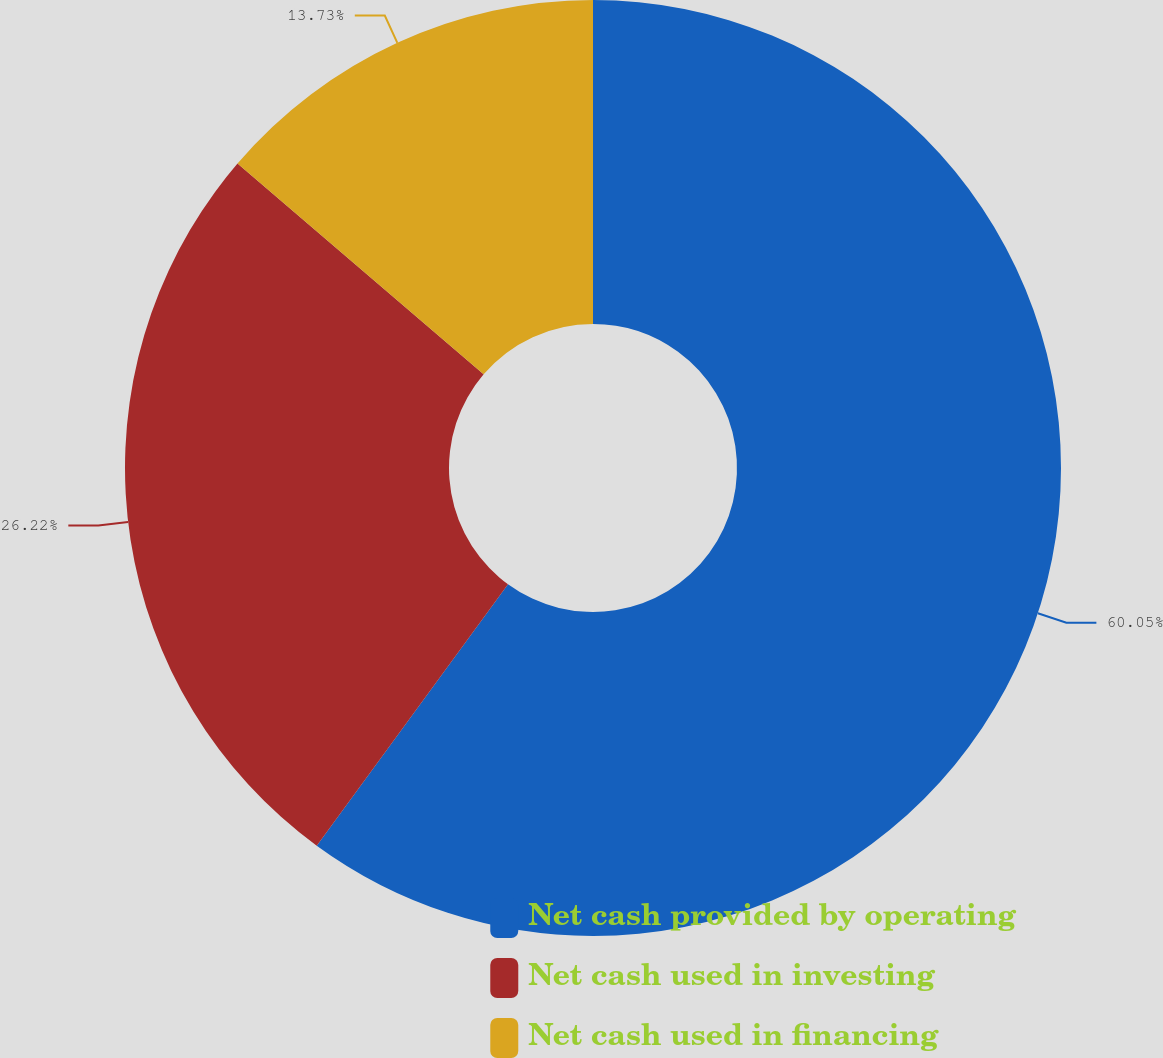<chart> <loc_0><loc_0><loc_500><loc_500><pie_chart><fcel>Net cash provided by operating<fcel>Net cash used in investing<fcel>Net cash used in financing<nl><fcel>60.05%<fcel>26.22%<fcel>13.73%<nl></chart> 